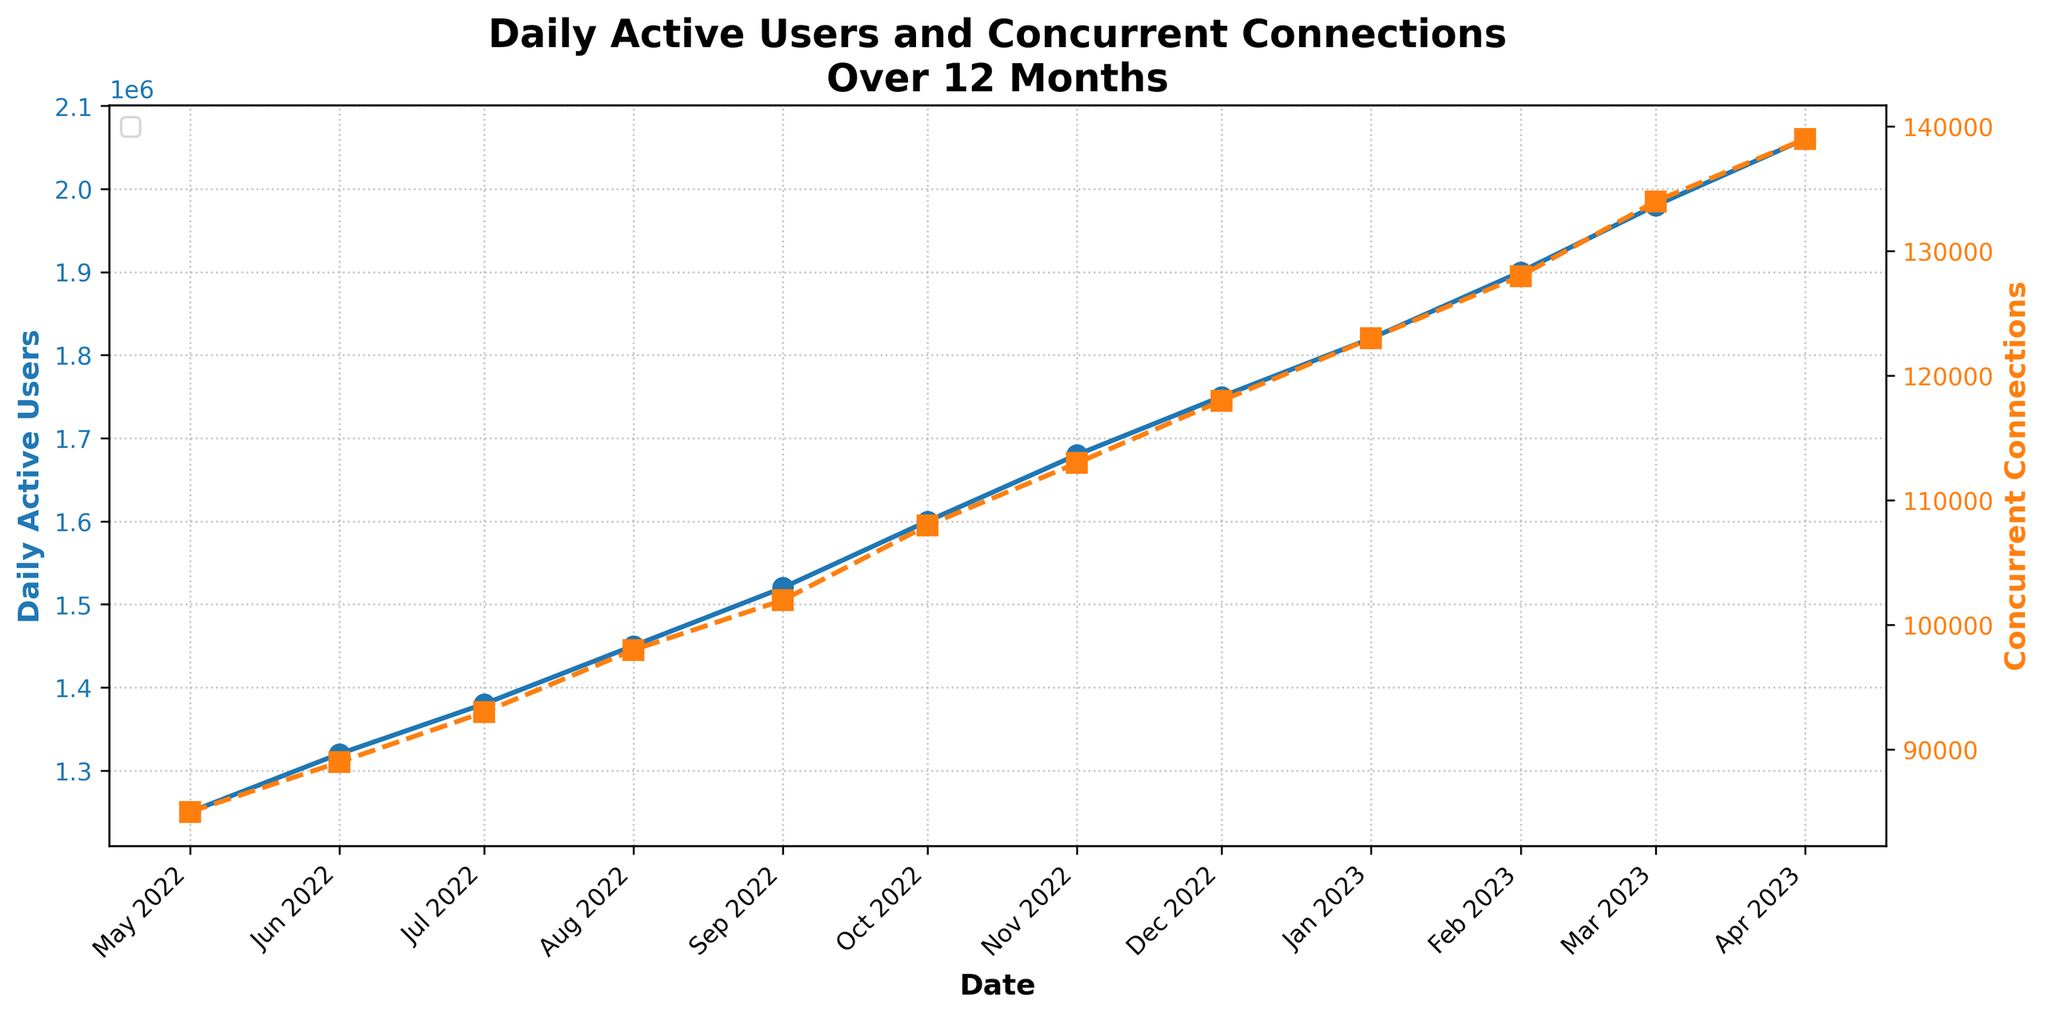What is the general trend for Daily Active Users over the twelve-month period? The trend for Daily Active Users is increasing. The data shows a steady rise from 1,250,000 in May 2022 to 2,060,000 in April 2023. This can be seen by the upward slope of the blue line.
Answer: Increasing Which month had the highest number of Concurrent Connections? The highest number of Concurrent Connections is in April 2023, with a value of 139,000. This can be observed at the peak point of the orange dashed line.
Answer: April 2023 In which month did both Daily Active Users and Concurrent Connections see the sharpest increase? The sharpest increase in both Daily Active Users and Concurrent Connections appears between January 2023 and February 2023. Daily Active Users increased by 80,000 while Concurrent Connections increased by 5,000. This can be seen by observing the steepest slopes in the corresponding lines within that time frame.
Answer: February 2023 What is the total increase in Daily Active Users from May 2022 to April 2023? The increase can be calculated by subtracting the initial value in May 2022 from the final value in April 2023: 2,060,000 - 1,250,000 = 810,000.
Answer: 810,000 How do the increases in Daily Active Users and Concurrent Connections from December 2022 to January 2023 compare? From December 2022 to January 2023, Daily Active Users increased by 70,000 (1,820,000 - 1,750,000) while Concurrent Connections increased by 5,000 (123,000 - 118,000). The increase in Daily Active Users is significantly larger than the increase in Concurrent Connections.
Answer: Daily Active Users increased more What is the average number of Concurrent Connections over the period? To find the average, sum up all Concurrent Connections values and divide by the number of months: (85,000 + 89,000 + 93,000 + 98,000 + 102,000 + 108,000 + 113,000 + 118,000 + 123,000 + 128,000 + 134,000 + 139,000) / 12 = 108,083.33.
Answer: 108,083 Which month shows the least amount of growth in Daily Active Users? The month with the least growth is June 2022, showing an increase of 70,000 Daily Active Users from the previous month (1,320,000 - 1,250,000). This is the smallest increment when compared to other months.
Answer: June 2022 How does the growth pattern of Concurrent Connections relate to that of Daily Active Users? Both Concurrent Connections and Daily Active Users show a consistently increasing pattern. The lines for both metrics move upwards consistently, indicating that as Daily Active Users increase, Concurrent Connections also rise.
Answer: Both increase consistently If the trends continue, what could be the projected Daily Active Users for May 2023? Assuming the consistent growth pattern continues, the increase can be estimated using the average monthly increase. From May 2022 to April 2023, the increase is 810,000 over 12 months, averaging 67,500 per month. Projecting this to May 2023: 2,060,000 + 67,500 = 2,127,500.
Answer: 2,127,500 